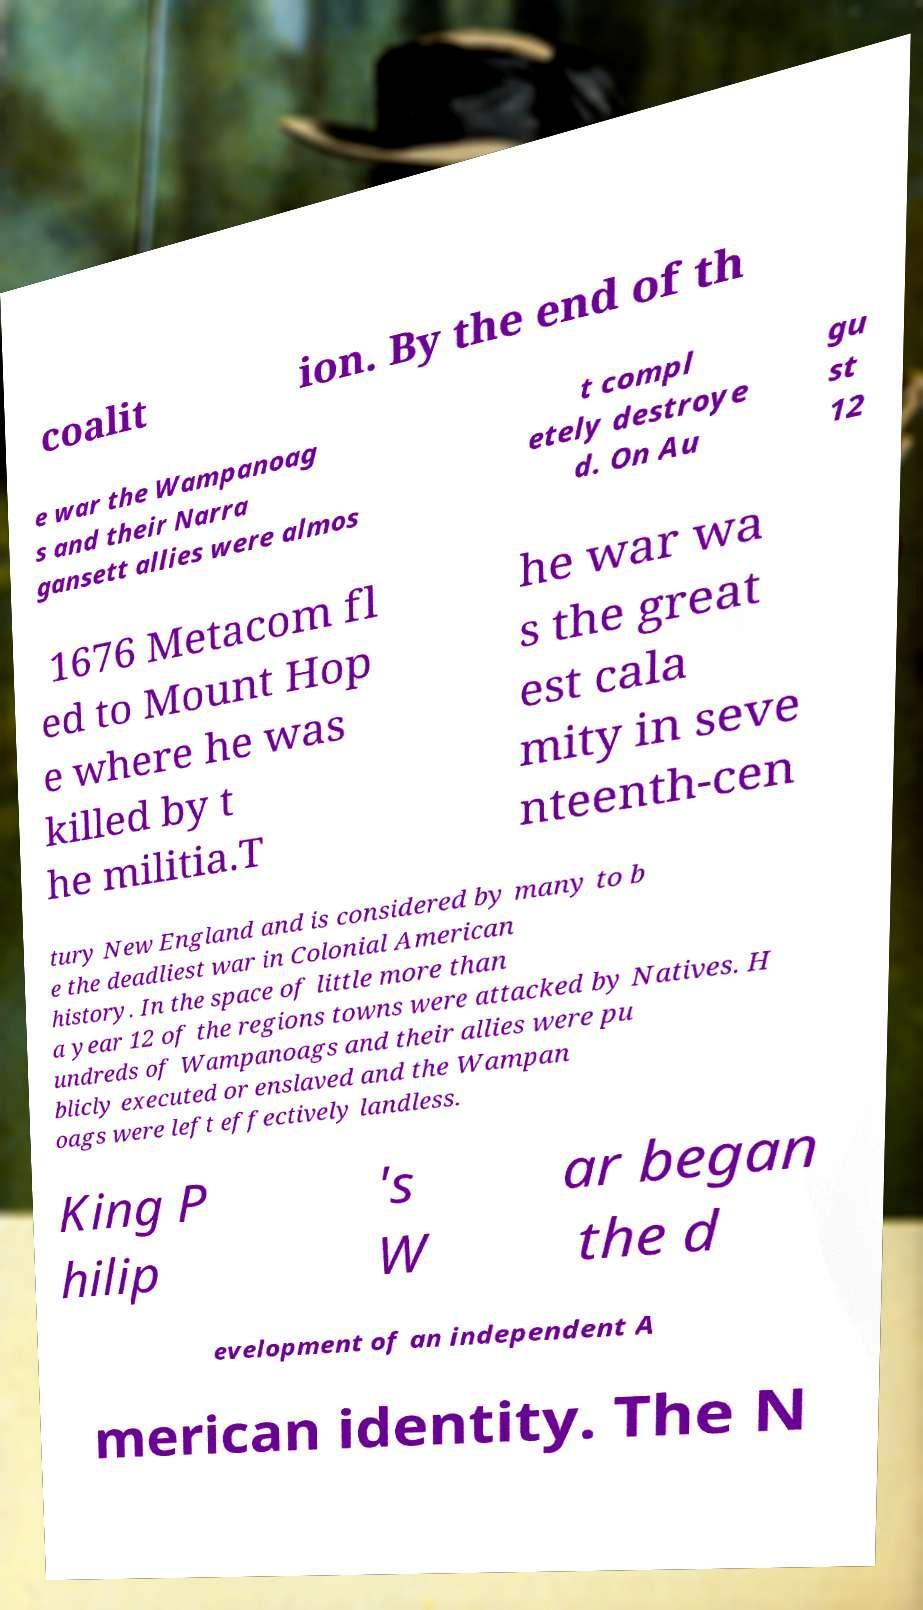What messages or text are displayed in this image? I need them in a readable, typed format. coalit ion. By the end of th e war the Wampanoag s and their Narra gansett allies were almos t compl etely destroye d. On Au gu st 12 1676 Metacom fl ed to Mount Hop e where he was killed by t he militia.T he war wa s the great est cala mity in seve nteenth-cen tury New England and is considered by many to b e the deadliest war in Colonial American history. In the space of little more than a year 12 of the regions towns were attacked by Natives. H undreds of Wampanoags and their allies were pu blicly executed or enslaved and the Wampan oags were left effectively landless. King P hilip 's W ar began the d evelopment of an independent A merican identity. The N 